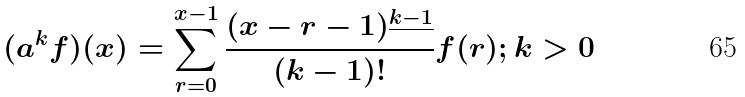Convert formula to latex. <formula><loc_0><loc_0><loc_500><loc_500>( a ^ { k } f ) ( x ) = \sum _ { r = 0 } ^ { x - 1 } \frac { ( x - r - 1 ) ^ { \underline { k - 1 } } } { ( k - 1 ) ! } f ( r ) ; k > 0</formula> 